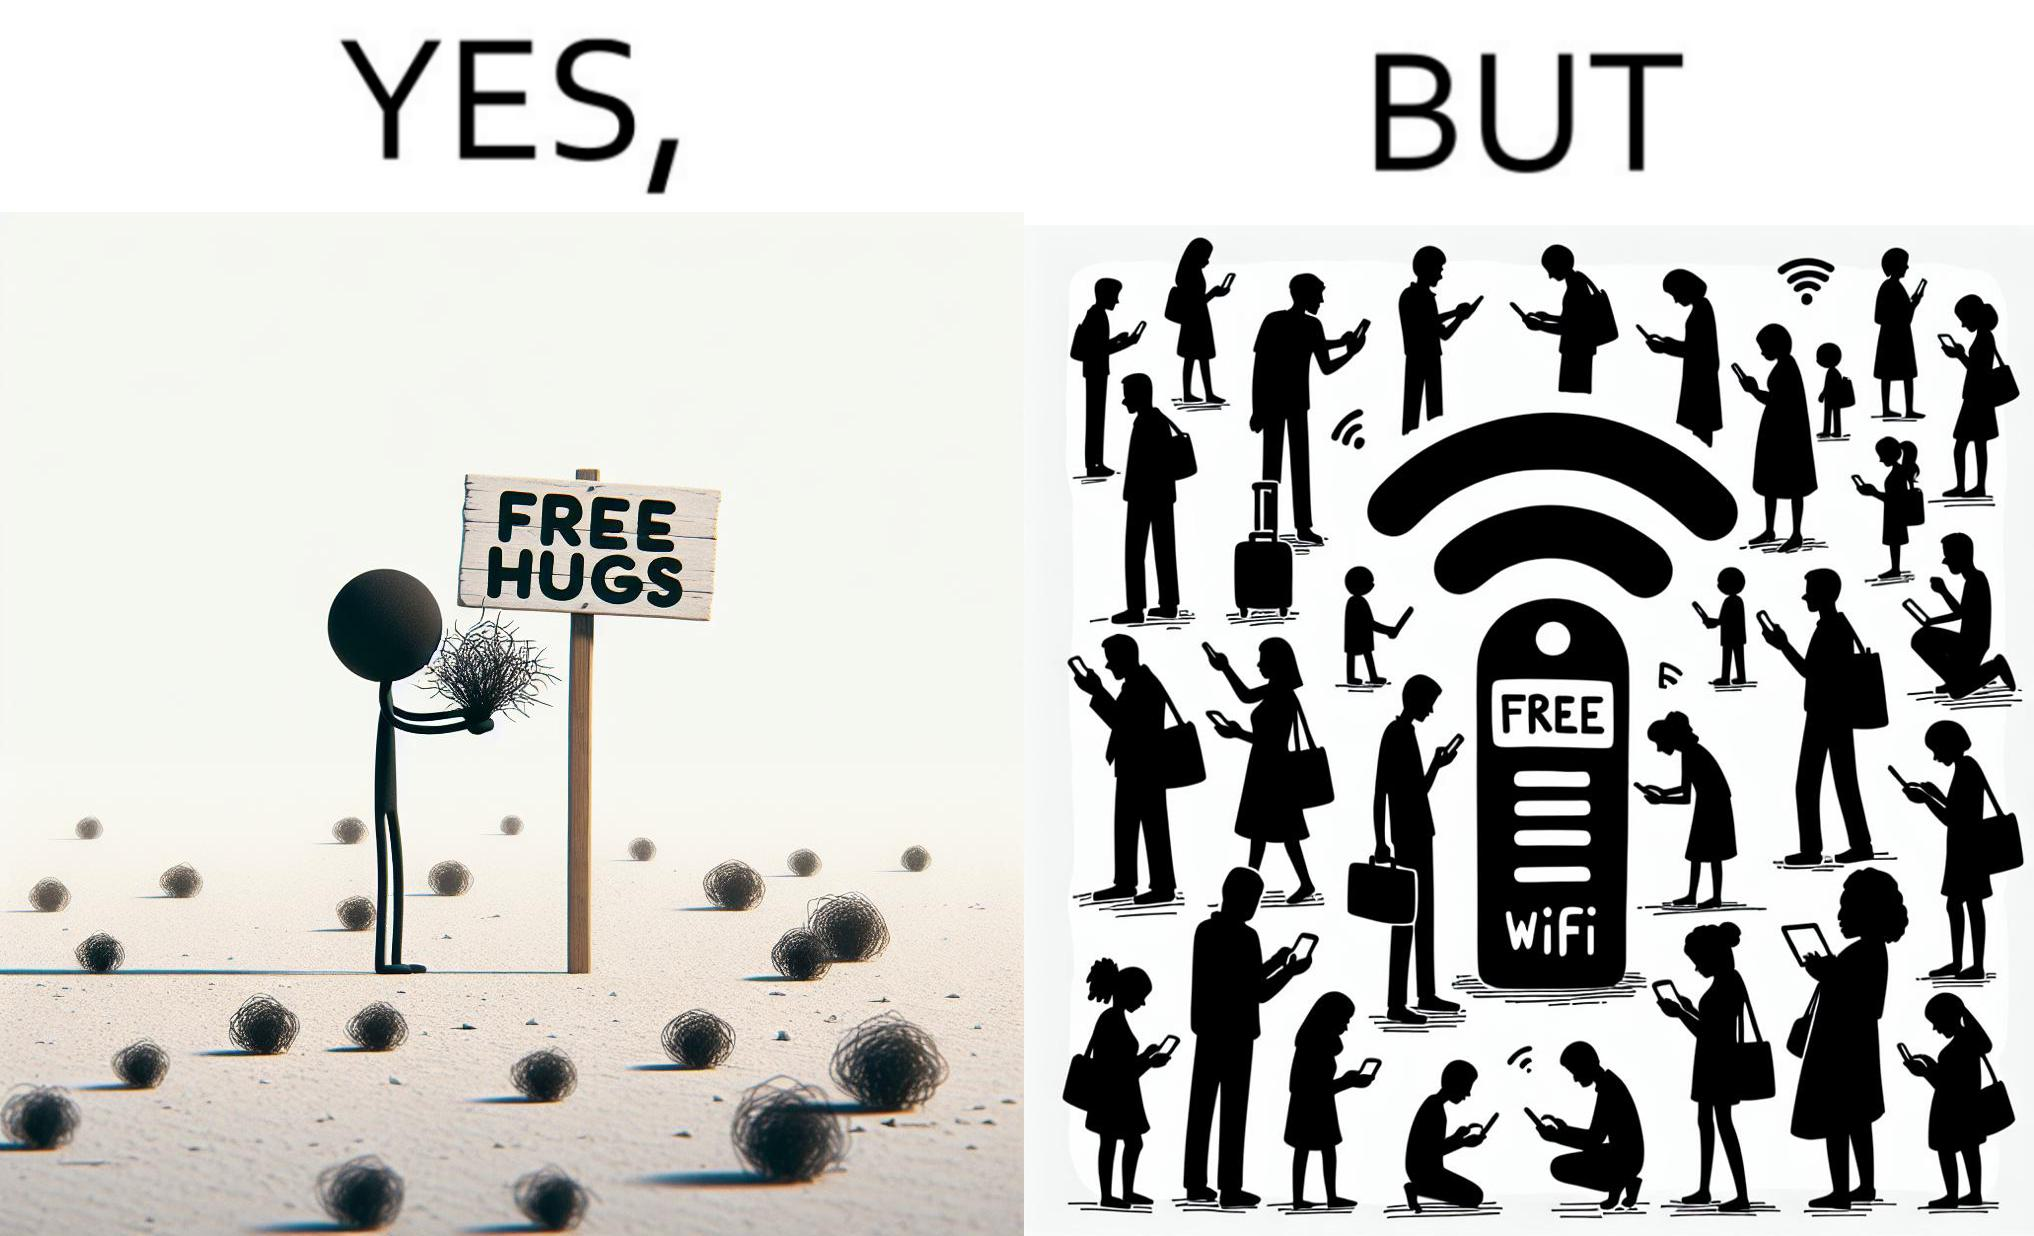Provide a description of this image. This image is ironical, as a person holding up a "Free Hugs" sign is standing alone, while an inanimate Wi-fi Router giving "Free Wifi" is surrounded people trying to connect to it. This shows a growing lack of empathy in our society, while showing our increasing dependence on the digital devices in a virtual world. 